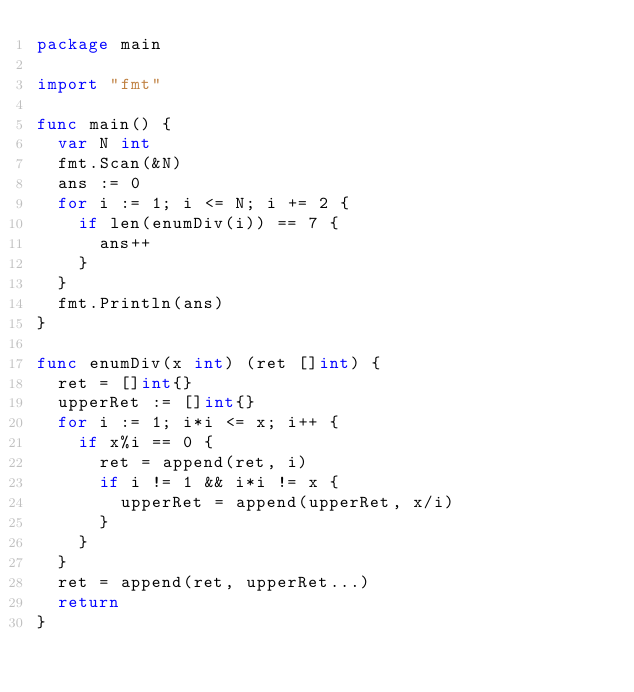<code> <loc_0><loc_0><loc_500><loc_500><_Go_>package main

import "fmt"

func main() {
	var N int
	fmt.Scan(&N)
	ans := 0
	for i := 1; i <= N; i += 2 {
		if len(enumDiv(i)) == 7 {
			ans++
		}
	}
	fmt.Println(ans)
}

func enumDiv(x int) (ret []int) {
	ret = []int{}
	upperRet := []int{}
	for i := 1; i*i <= x; i++ {
		if x%i == 0 {
			ret = append(ret, i)
			if i != 1 && i*i != x {
				upperRet = append(upperRet, x/i)
			}
		}
	}
	ret = append(ret, upperRet...)
	return
}
</code> 